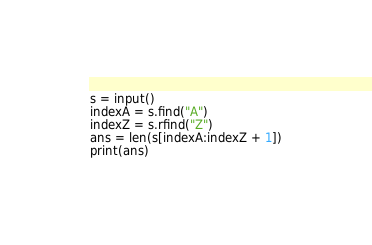Convert code to text. <code><loc_0><loc_0><loc_500><loc_500><_Python_>s = input()
indexA = s.find("A")
indexZ = s.rfind("Z")
ans = len(s[indexA:indexZ + 1])
print(ans)</code> 